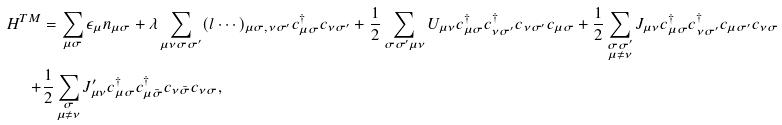<formula> <loc_0><loc_0><loc_500><loc_500>H ^ { T M } & = \sum _ { \mu \sigma } \epsilon _ { \mu } n _ { \mu \sigma } + \lambda \sum _ { \mu \nu \sigma \sigma ^ { \prime } } ( l \cdots ) _ { \mu \sigma , \nu \sigma ^ { \prime } } c _ { \mu \sigma } ^ { \dagger } c _ { \nu \sigma ^ { \prime } } + \frac { 1 } { 2 } \sum _ { \sigma \sigma ^ { \prime } \mu \nu } U _ { \mu \nu } c _ { \mu \sigma } ^ { \dagger } c _ { \nu \sigma ^ { \prime } } ^ { \dagger } c _ { \nu \sigma ^ { \prime } } c _ { \mu \sigma } + \frac { 1 } { 2 } \sum _ { \substack { \sigma \sigma ^ { \prime } \\ \mu \ne \nu } } J _ { \mu \nu } c _ { \mu \sigma } ^ { \dagger } c _ { \nu \sigma ^ { \prime } } ^ { \dagger } c _ { \mu \sigma ^ { \prime } } c _ { \nu \sigma } \\ + & \frac { 1 } { 2 } \sum _ { \substack { \sigma \\ \mu \ne \nu } } J _ { \mu \nu } ^ { \prime } c _ { \mu \sigma } ^ { \dagger } c _ { \mu \bar { \sigma } } ^ { \dagger } c _ { \nu \bar { \sigma } } c _ { \nu \sigma } ,</formula> 